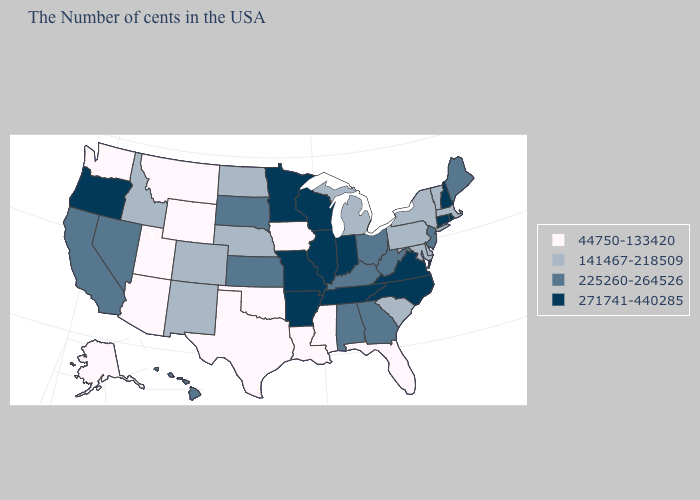What is the lowest value in the South?
Quick response, please. 44750-133420. Which states have the lowest value in the USA?
Concise answer only. Florida, Mississippi, Louisiana, Iowa, Oklahoma, Texas, Wyoming, Utah, Montana, Arizona, Washington, Alaska. What is the highest value in the USA?
Quick response, please. 271741-440285. How many symbols are there in the legend?
Be succinct. 4. Name the states that have a value in the range 271741-440285?
Quick response, please. Rhode Island, New Hampshire, Connecticut, Virginia, North Carolina, Indiana, Tennessee, Wisconsin, Illinois, Missouri, Arkansas, Minnesota, Oregon. Name the states that have a value in the range 44750-133420?
Give a very brief answer. Florida, Mississippi, Louisiana, Iowa, Oklahoma, Texas, Wyoming, Utah, Montana, Arizona, Washington, Alaska. What is the highest value in the USA?
Short answer required. 271741-440285. How many symbols are there in the legend?
Concise answer only. 4. What is the lowest value in the MidWest?
Concise answer only. 44750-133420. What is the value of New Mexico?
Quick response, please. 141467-218509. Does Iowa have the lowest value in the MidWest?
Quick response, please. Yes. How many symbols are there in the legend?
Short answer required. 4. What is the value of Pennsylvania?
Concise answer only. 141467-218509. Name the states that have a value in the range 141467-218509?
Write a very short answer. Massachusetts, Vermont, New York, Delaware, Maryland, Pennsylvania, South Carolina, Michigan, Nebraska, North Dakota, Colorado, New Mexico, Idaho. 